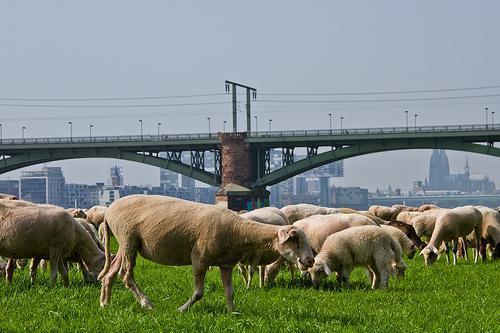How many bridges are in the photo?
Give a very brief answer. 1. 